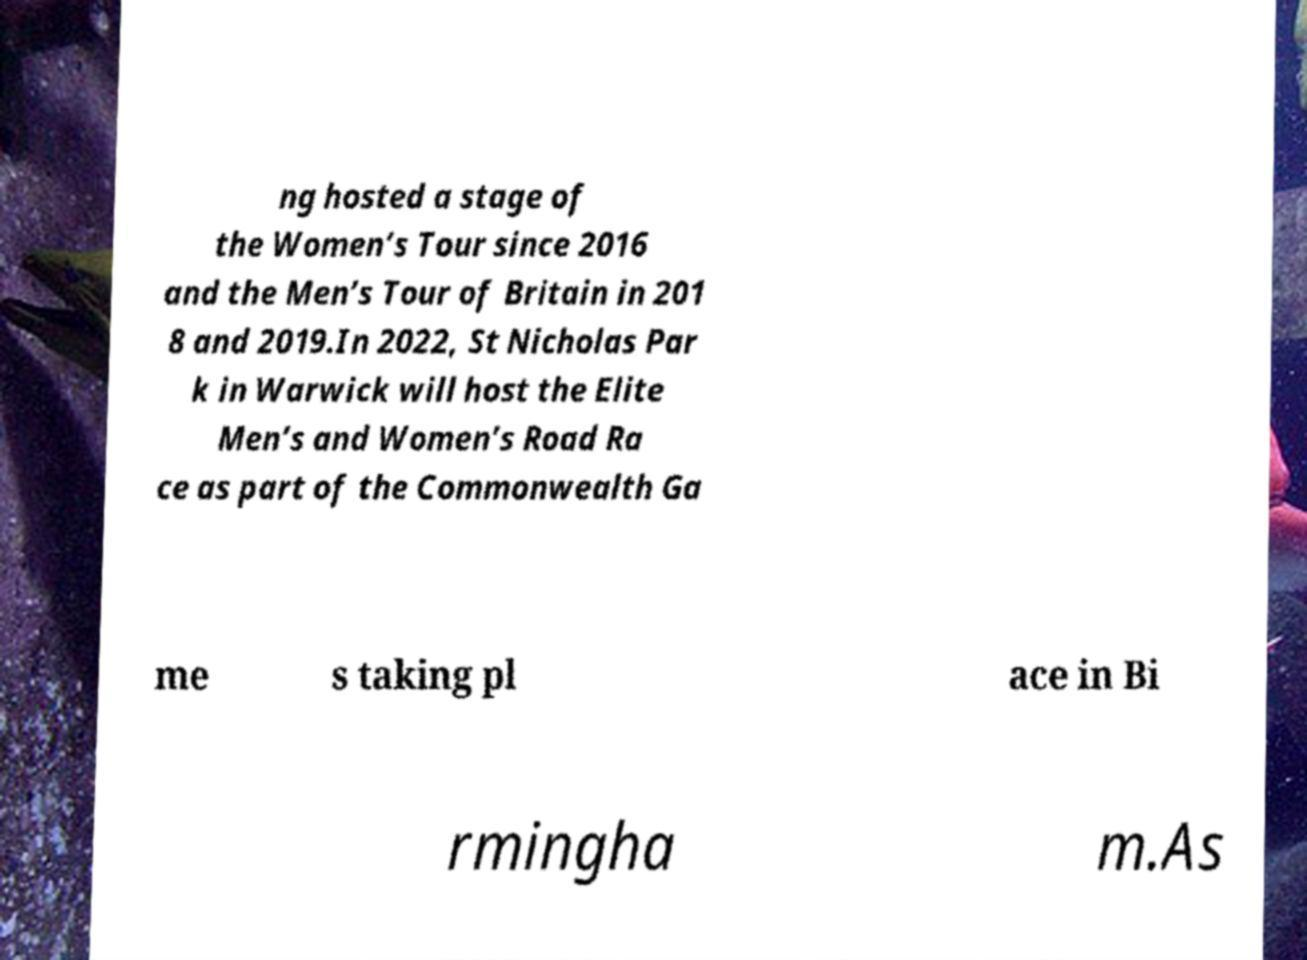I need the written content from this picture converted into text. Can you do that? ng hosted a stage of the Women’s Tour since 2016 and the Men’s Tour of Britain in 201 8 and 2019.In 2022, St Nicholas Par k in Warwick will host the Elite Men’s and Women’s Road Ra ce as part of the Commonwealth Ga me s taking pl ace in Bi rmingha m.As 